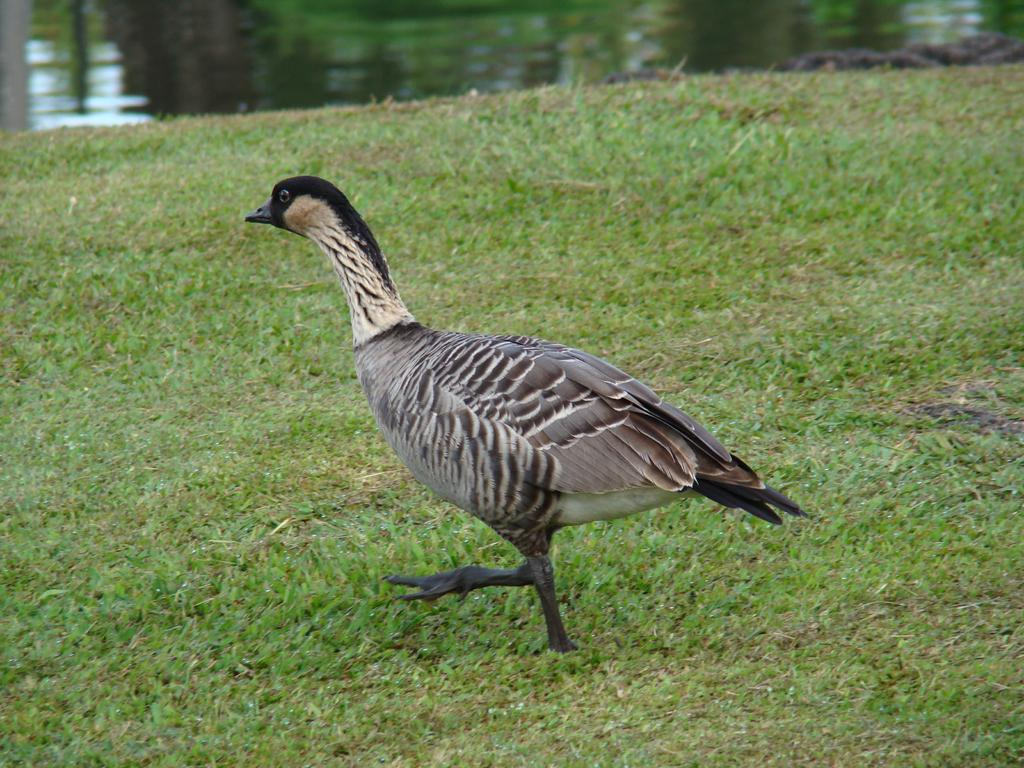What animal can be seen in the image? There is a duck in the image. Where is the duck located? The duck is standing on the grass. What can be seen in the background of the image? There is water visible in the background of the image. How many clocks are hanging on the duck's leg in the image? There are no clocks present in the image, and the duck does not have any legs visible. 